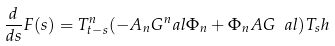<formula> <loc_0><loc_0><loc_500><loc_500>\frac { d } { d s } F ( s ) = T ^ { n } _ { t - s } ( - A _ { n } G ^ { n } _ { \ } a l \Phi _ { n } + \Phi _ { n } A G _ { \ } a l ) T _ { s } h</formula> 